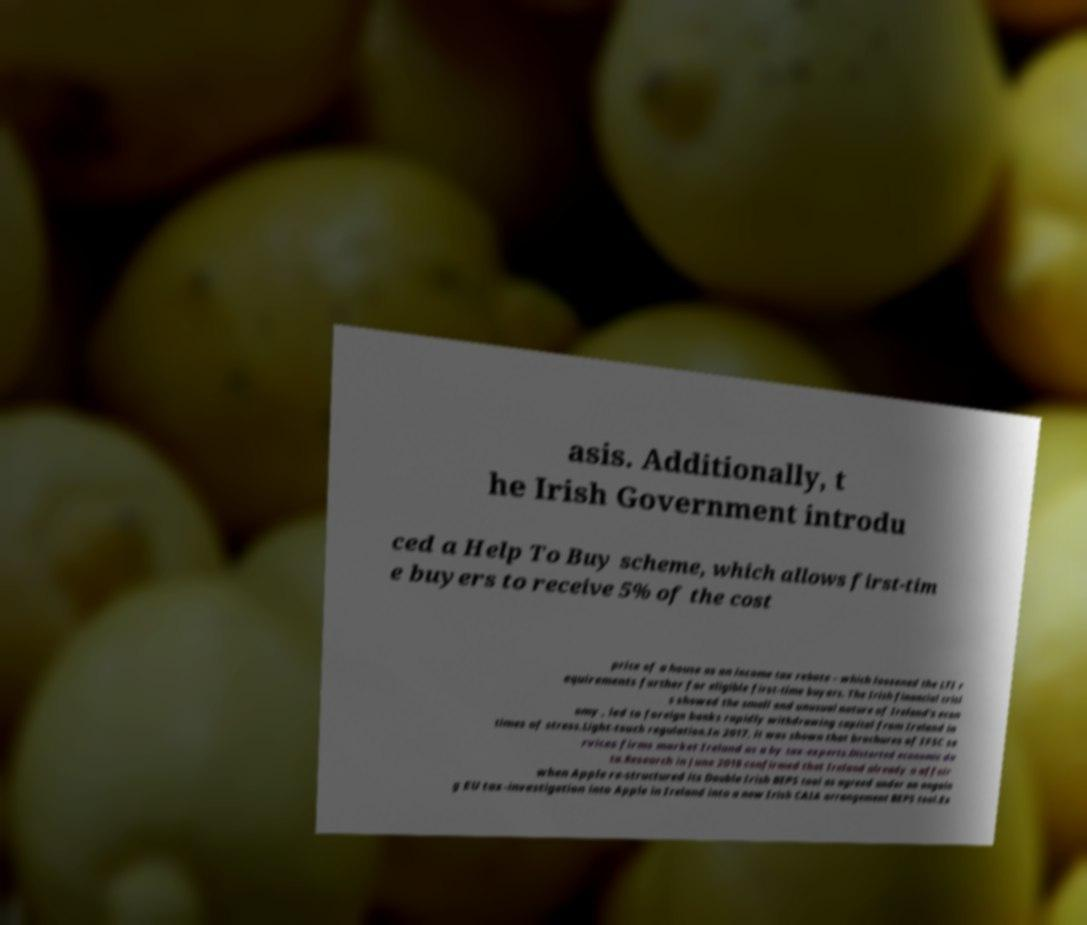Could you assist in decoding the text presented in this image and type it out clearly? asis. Additionally, t he Irish Government introdu ced a Help To Buy scheme, which allows first-tim e buyers to receive 5% of the cost price of a house as an income tax rebate – which loosened the LTI r equirements further for eligible first-time buyers. The Irish financial crisi s showed the small and unusual nature of Ireland's econ omy , led to foreign banks rapidly withdrawing capital from Ireland in times of stress.Light-touch regulation.In 2017, it was shown that brochures of IFSC se rvices firms market Ireland as a by tax-experts.Distorted economic da ta.Research in June 2018 confirmed that Ireland already a affair when Apple re-structured its Double Irish BEPS tool as agreed under an ongoin g EU tax-investigation into Apple in Ireland into a new Irish CAIA arrangement BEPS tool.Ex 